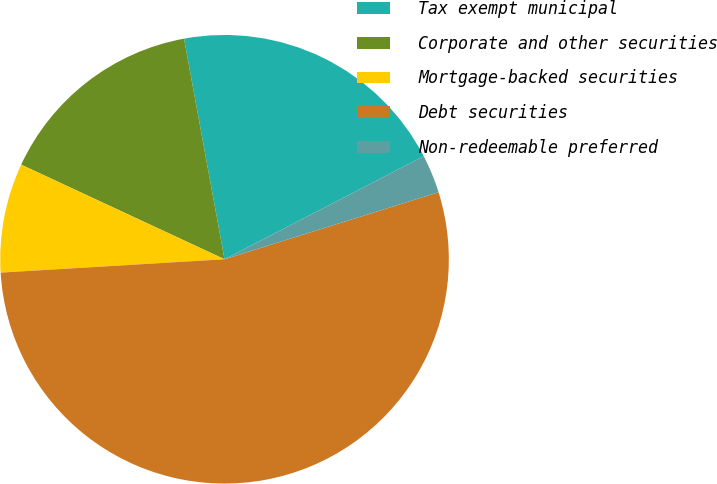Convert chart to OTSL. <chart><loc_0><loc_0><loc_500><loc_500><pie_chart><fcel>Tax exempt municipal<fcel>Corporate and other securities<fcel>Mortgage-backed securities<fcel>Debt securities<fcel>Non-redeemable preferred<nl><fcel>20.29%<fcel>15.18%<fcel>7.88%<fcel>53.88%<fcel>2.77%<nl></chart> 